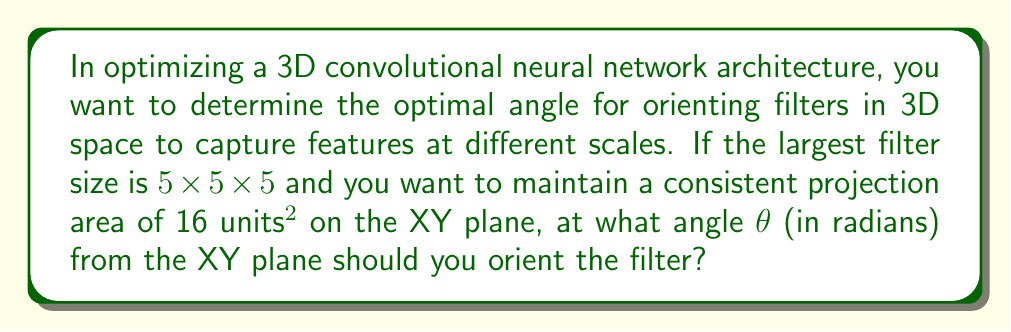Teach me how to tackle this problem. Let's approach this step-by-step:

1) The filter is a cube with side length 5 units. Its diagonal can be calculated using the 3D version of the Pythagorean theorem:

   $$d = \sqrt{5^2 + 5^2 + 5^2} = 5\sqrt{3}$$

2) We want to find the angle θ at which this diagonal makes with the XY plane such that its projection on this plane has an area of 16 units².

3) The projection of this cube on the XY plane will be a regular hexagon. The area of a regular hexagon is given by:

   $$A = \frac{3\sqrt{3}}{2}a^2$$

   where a is the side length of the hexagon.

4) We know A = 16, so we can solve for a:

   $$16 = \frac{3\sqrt{3}}{2}a^2$$
   $$a^2 = \frac{32}{3\sqrt{3}}$$
   $$a = \sqrt{\frac{32}{3\sqrt{3}}} \approx 2.3094$$

5) This side length a is the projection of the cube's diagonal on the XY plane. We can use this to find θ:

   $$\cos θ = \frac{a}{d} = \frac{\sqrt{\frac{32}{3\sqrt{3}}}}{5\sqrt{3}}$$

6) Simplifying:

   $$\cos θ = \frac{\sqrt{32}}{5 \cdot 3^{3/4}} \approx 0.5373$$

7) Therefore:

   $$θ = \arccos(\frac{\sqrt{32}}{5 \cdot 3^{3/4}})$$
Answer: $\arccos(\frac{\sqrt{32}}{5 \cdot 3^{3/4}})$ radians 